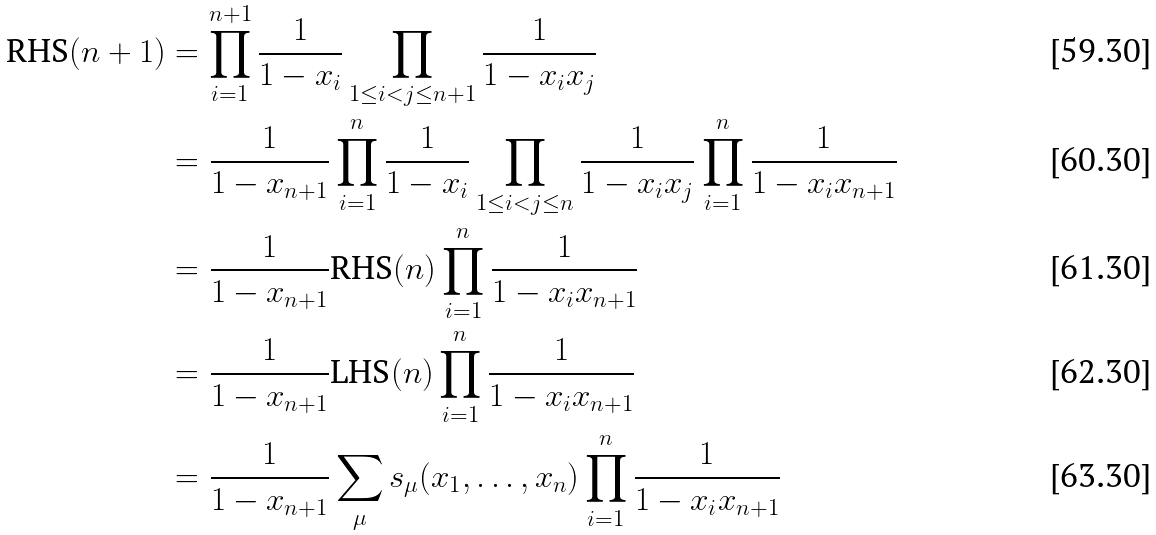Convert formula to latex. <formula><loc_0><loc_0><loc_500><loc_500>\text {RHS} ( n + 1 ) & = \prod _ { i = 1 } ^ { n + 1 } \frac { 1 } { 1 - x _ { i } } \prod _ { 1 \leq i < j \leq n + 1 } \frac { 1 } { 1 - x _ { i } x _ { j } } \\ & = \frac { 1 } { 1 - x _ { n + 1 } } \prod _ { i = 1 } ^ { n } \frac { 1 } { 1 - x _ { i } } \prod _ { 1 \leq i < j \leq n } \frac { 1 } { 1 - x _ { i } x _ { j } } \prod _ { i = 1 } ^ { n } \frac { 1 } { 1 - x _ { i } x _ { n + 1 } } \\ & = \frac { 1 } { 1 - x _ { n + 1 } } \text {RHS} ( n ) \prod _ { i = 1 } ^ { n } \frac { 1 } { 1 - x _ { i } x _ { n + 1 } } \\ & = \frac { 1 } { 1 - x _ { n + 1 } } \text {LHS} ( n ) \prod _ { i = 1 } ^ { n } \frac { 1 } { 1 - x _ { i } x _ { n + 1 } } \\ & = \frac { 1 } { 1 - x _ { n + 1 } } \sum _ { \mu } s _ { \mu } ( x _ { 1 } , \dots , x _ { n } ) \prod _ { i = 1 } ^ { n } \frac { 1 } { 1 - x _ { i } x _ { n + 1 } }</formula> 